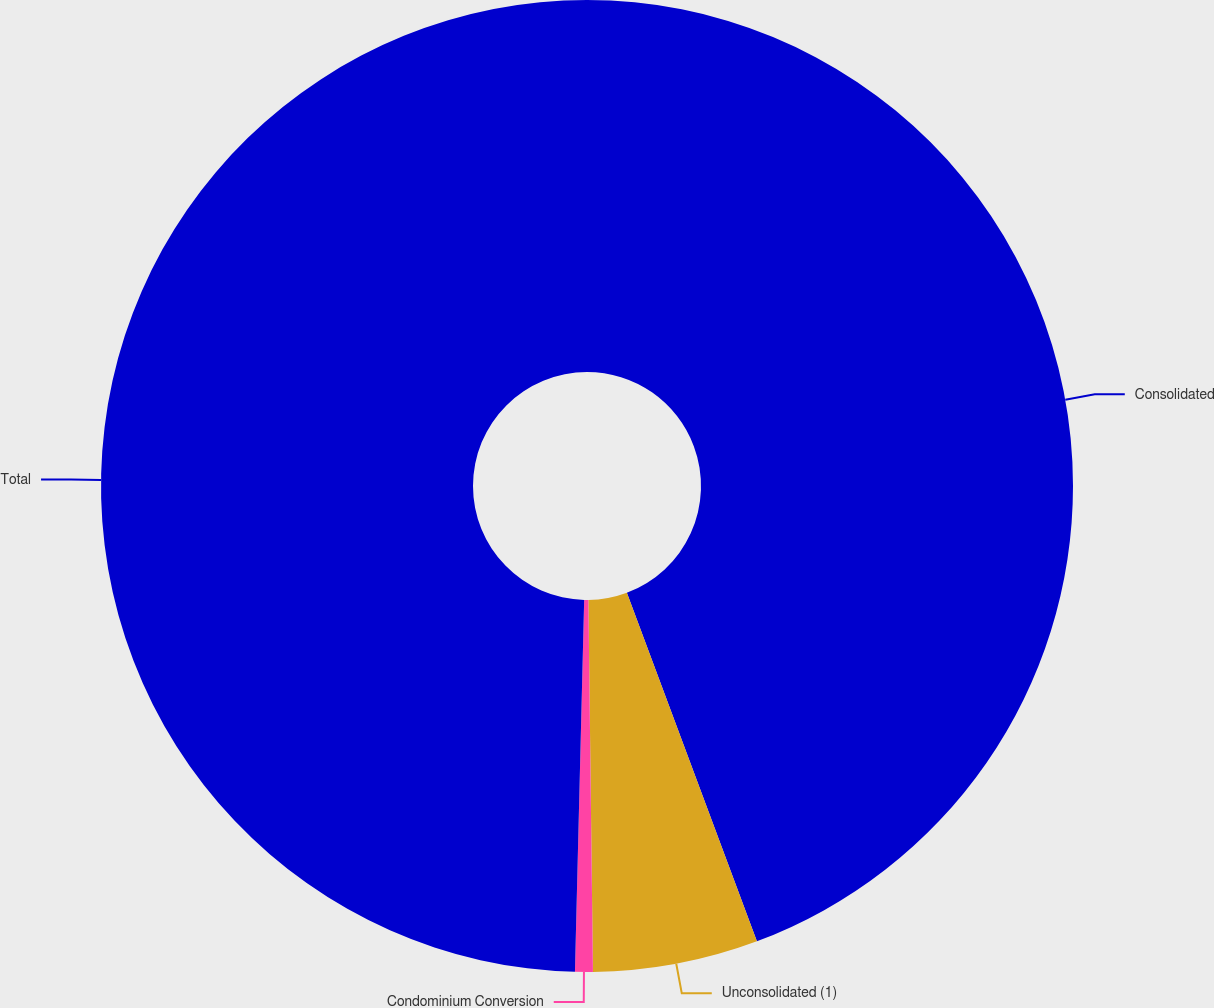Convert chart to OTSL. <chart><loc_0><loc_0><loc_500><loc_500><pie_chart><fcel>Consolidated<fcel>Unconsolidated (1)<fcel>Condominium Conversion<fcel>Total<nl><fcel>44.32%<fcel>5.49%<fcel>0.59%<fcel>49.61%<nl></chart> 